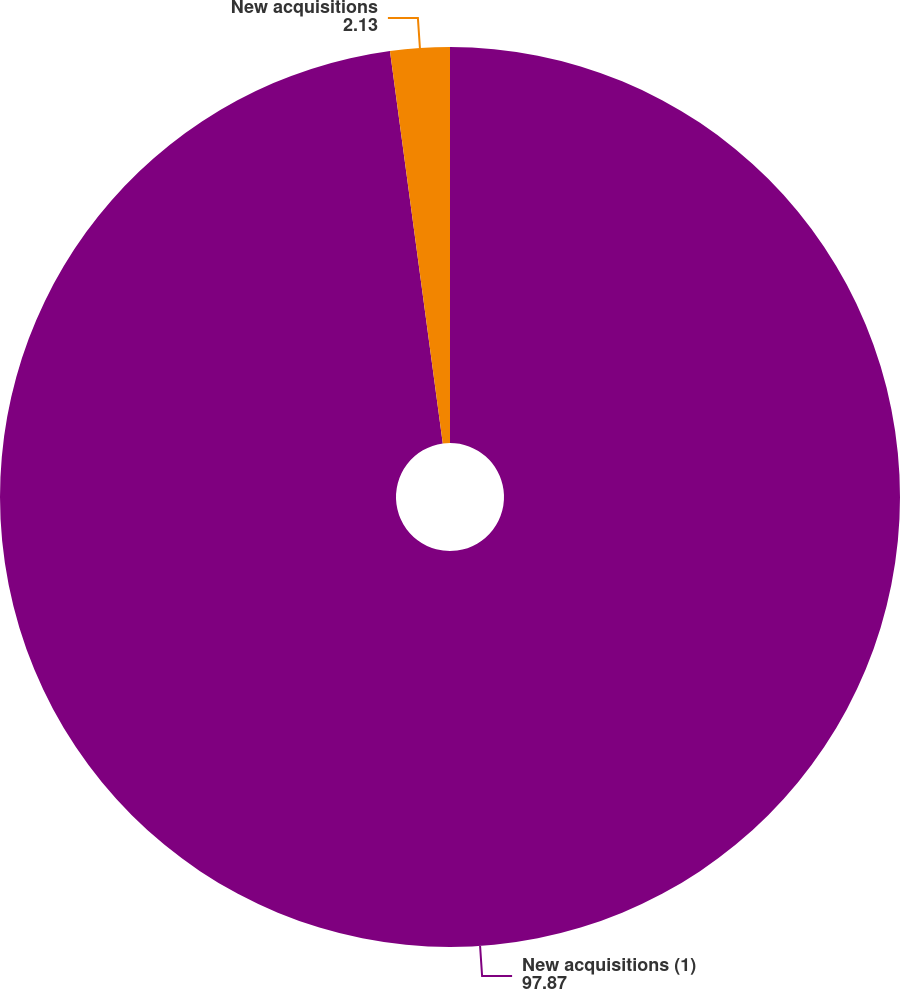Convert chart. <chart><loc_0><loc_0><loc_500><loc_500><pie_chart><fcel>New acquisitions (1)<fcel>New acquisitions<nl><fcel>97.87%<fcel>2.13%<nl></chart> 